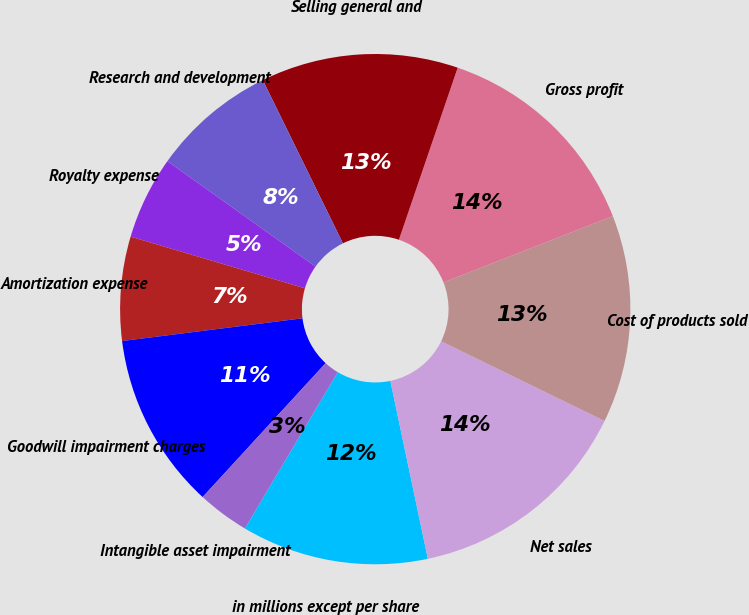Convert chart. <chart><loc_0><loc_0><loc_500><loc_500><pie_chart><fcel>in millions except per share<fcel>Net sales<fcel>Cost of products sold<fcel>Gross profit<fcel>Selling general and<fcel>Research and development<fcel>Royalty expense<fcel>Amortization expense<fcel>Goodwill impairment charges<fcel>Intangible asset impairment<nl><fcel>11.84%<fcel>14.47%<fcel>13.16%<fcel>13.82%<fcel>12.5%<fcel>7.89%<fcel>5.26%<fcel>6.58%<fcel>11.18%<fcel>3.29%<nl></chart> 